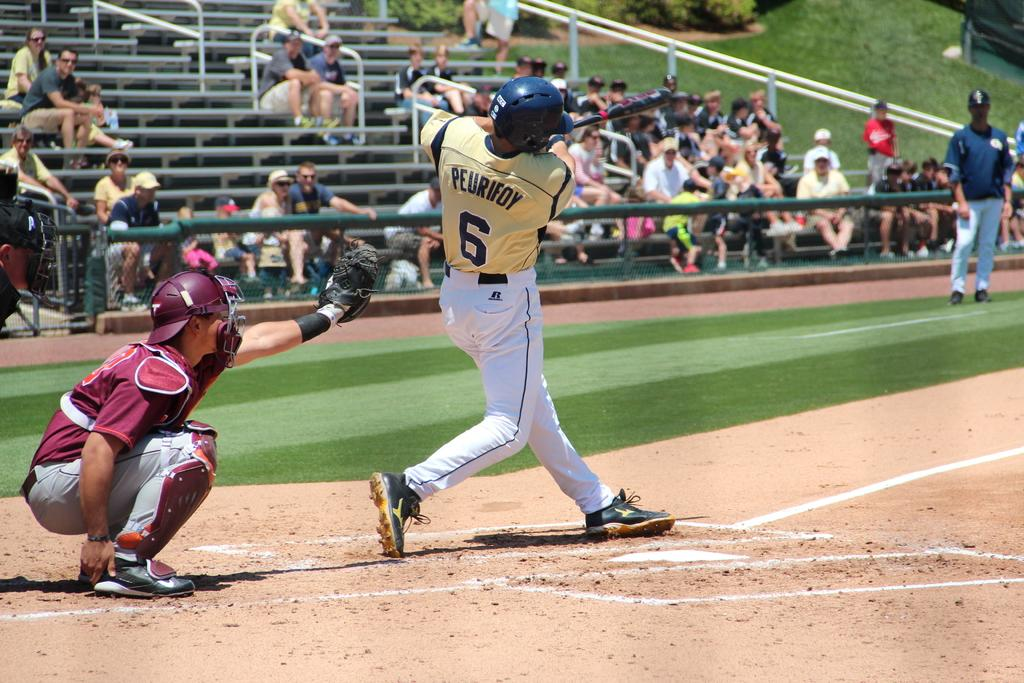<image>
Give a short and clear explanation of the subsequent image. The player at bat is wearing the name Peurifoy 